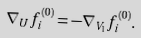Convert formula to latex. <formula><loc_0><loc_0><loc_500><loc_500>\nabla _ { U } f _ { i } ^ { ( 0 ) } = - \nabla _ { V _ { 1 } } f _ { i } ^ { ( 0 ) } .</formula> 